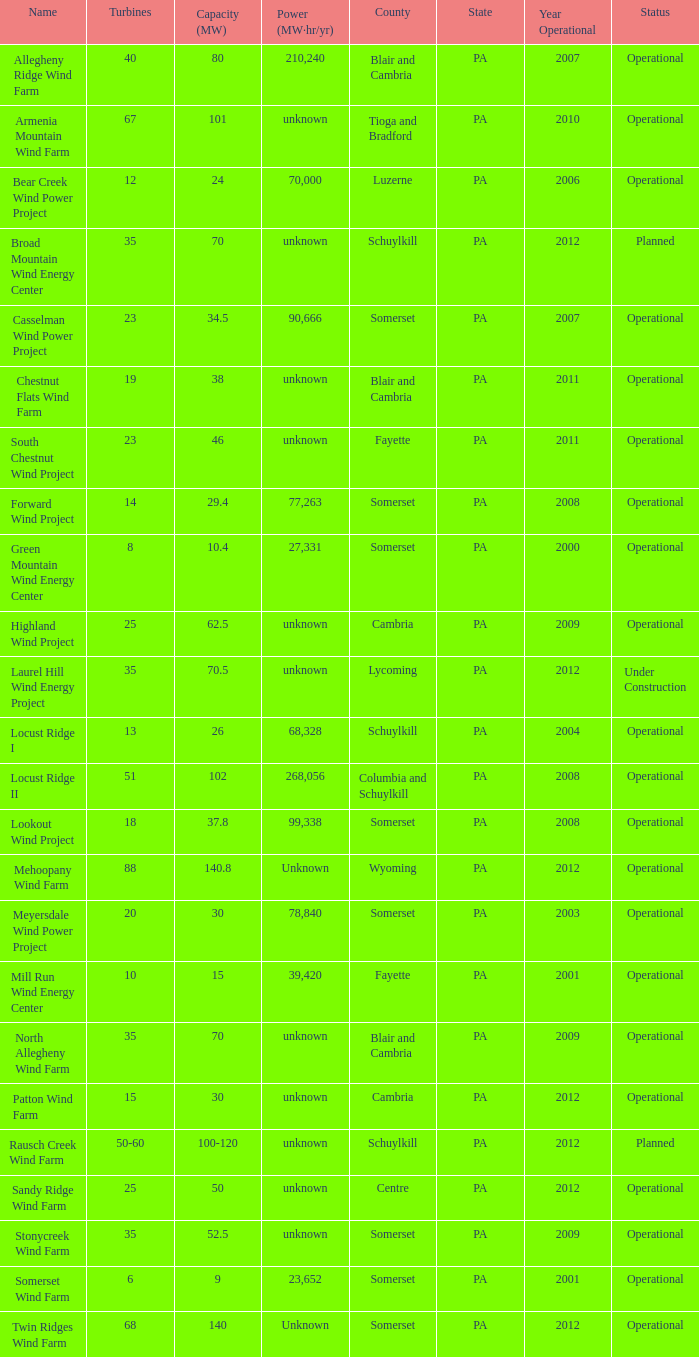Which farm with a capacity of 70 is currently functioning? North Allegheny Wind Farm. 